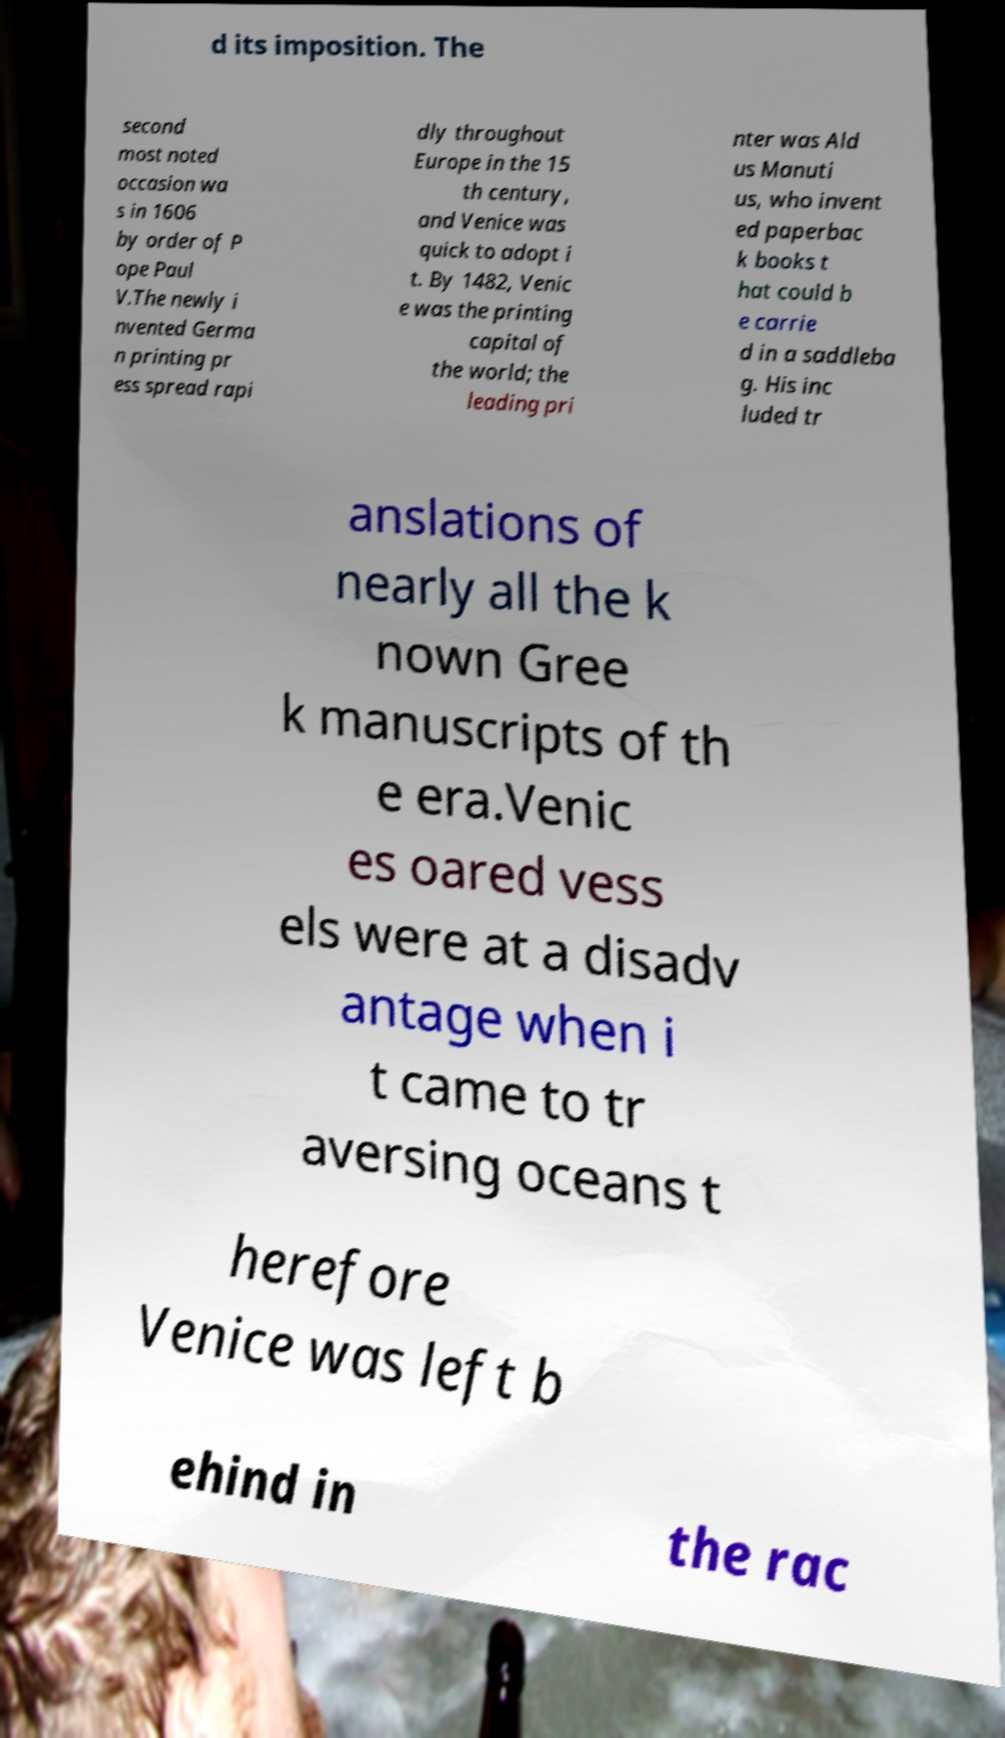Could you assist in decoding the text presented in this image and type it out clearly? d its imposition. The second most noted occasion wa s in 1606 by order of P ope Paul V.The newly i nvented Germa n printing pr ess spread rapi dly throughout Europe in the 15 th century, and Venice was quick to adopt i t. By 1482, Venic e was the printing capital of the world; the leading pri nter was Ald us Manuti us, who invent ed paperbac k books t hat could b e carrie d in a saddleba g. His inc luded tr anslations of nearly all the k nown Gree k manuscripts of th e era.Venic es oared vess els were at a disadv antage when i t came to tr aversing oceans t herefore Venice was left b ehind in the rac 